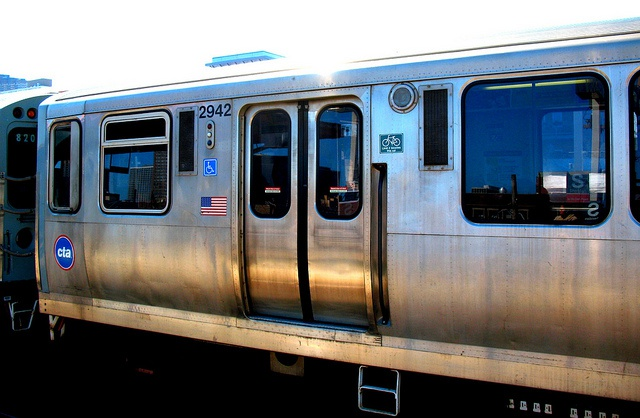Describe the objects in this image and their specific colors. I can see a train in white, black, darkgray, and tan tones in this image. 